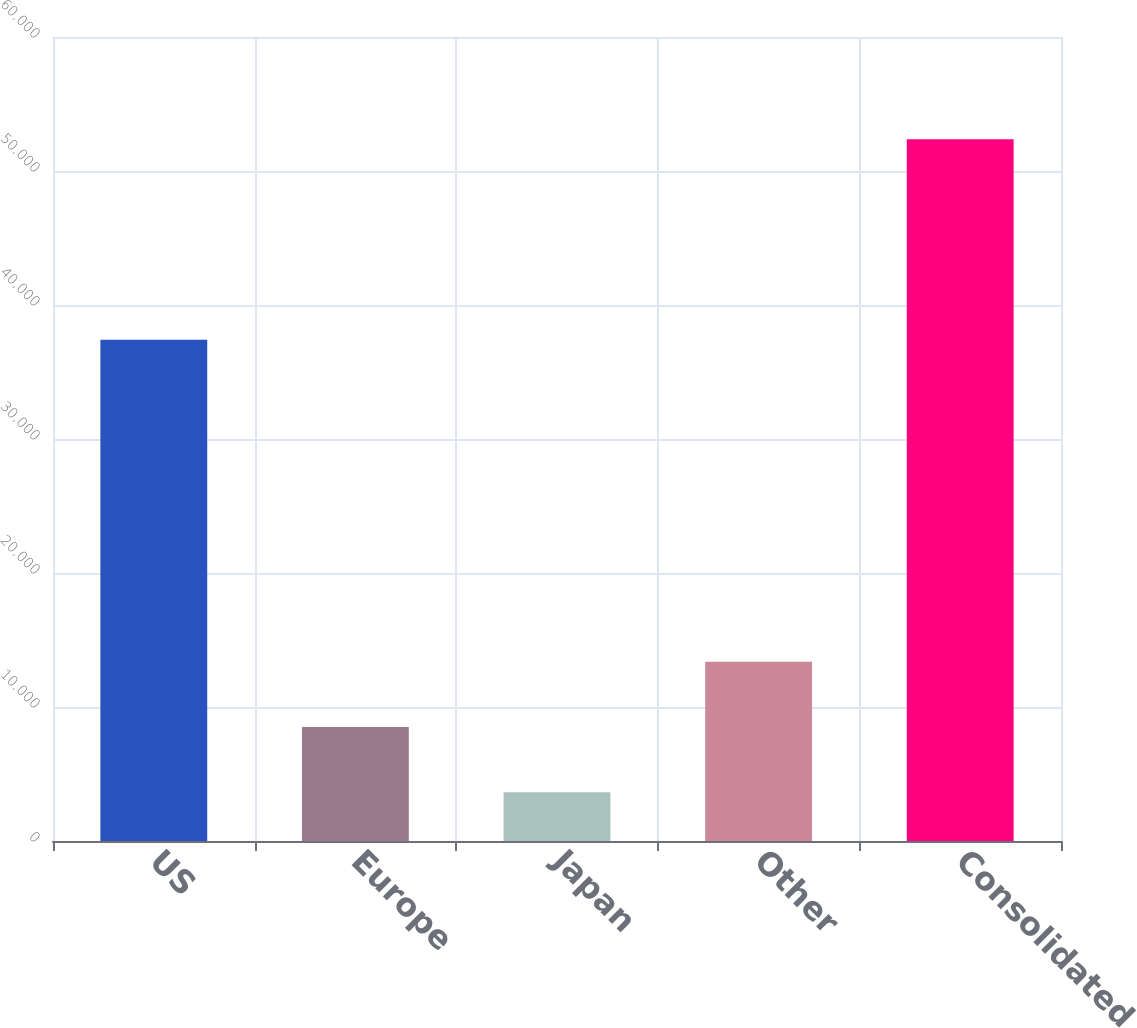Convert chart to OTSL. <chart><loc_0><loc_0><loc_500><loc_500><bar_chart><fcel>US<fcel>Europe<fcel>Japan<fcel>Other<fcel>Consolidated<nl><fcel>37405<fcel>8509.1<fcel>3636<fcel>13382.2<fcel>52367<nl></chart> 